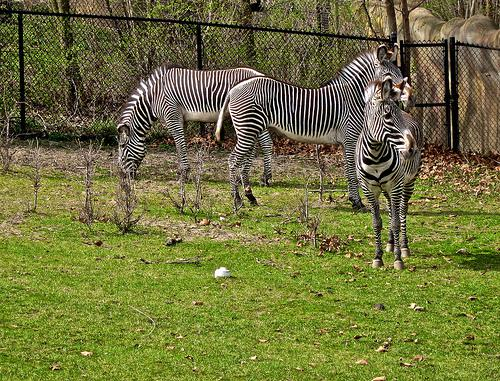Question: what type of animals are shown?
Choices:
A. Horses.
B. Cows.
C. Zebras.
D. Pigs.
Answer with the letter. Answer: C Question: where are the zebras?
Choices:
A. In the zoo.
B. In a cage.
C. Field.
D. In the river.
Answer with the letter. Answer: C Question: what keeps the zebras in their area?
Choices:
A. Hunters.
B. Cage.
C. Fence.
D. Walls.
Answer with the letter. Answer: C Question: what are the zebras standing on?
Choices:
A. Concrete.
B. Sand.
C. Water.
D. Grass.
Answer with the letter. Answer: D Question: how many zebras are there?
Choices:
A. Two.
B. One.
C. Four.
D. Three.
Answer with the letter. Answer: D 